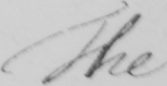What is written in this line of handwriting? The 